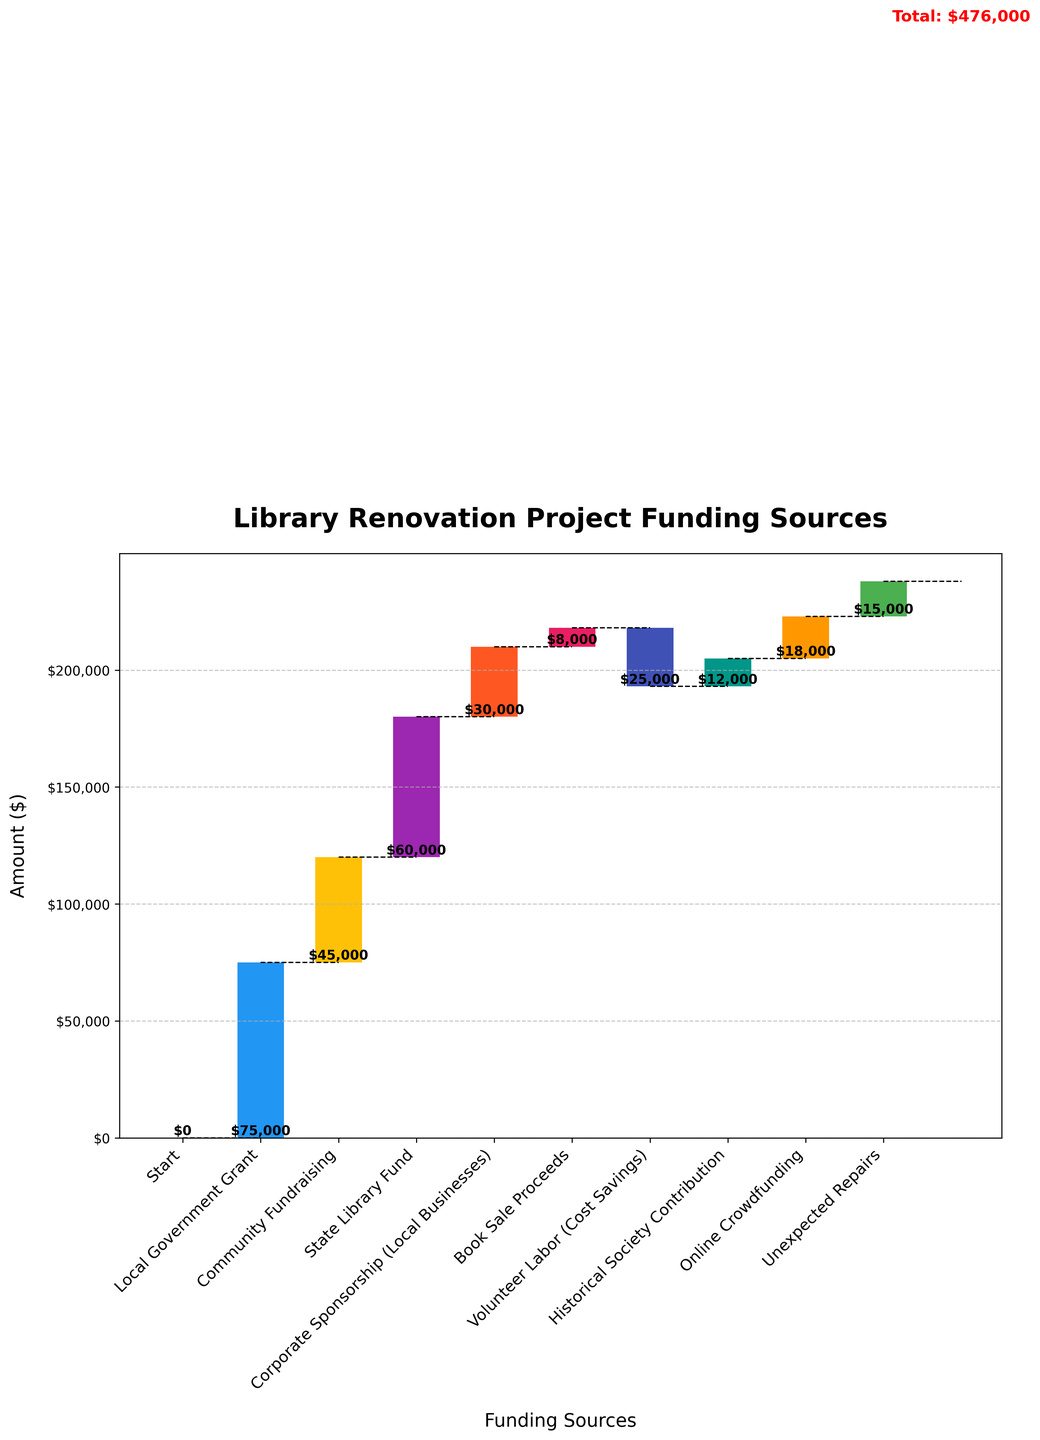What is the title of the chart? The title is displayed at the top of the chart. It is written in bold and large font.
Answer: Library Renovation Project Funding Sources What is the total amount of funding for the library renovation project? The total amount is shown as the last bar labeled "Total" in the chart, with a red value indicator.
Answer: $238,000 How much was contributed through local government grants? The contribution is shown as the first category bar after "Start".
Answer: $75,000 Which funding source contributed the least amount? To determine the least contribution, look for the smallest positive bar height in the chart.
Answer: Book Sale Proceeds ($8,000) How much cost savings was achieved through volunteer labor? The volunteer labor contribution is represented with a negative value, shown as a downward bar.
Answer: -$25,000 Which funding source contributed more, the State Library Fund or Corporate Sponsorship (Local Businesses)? Compare the heights of the bars labeled "State Library Fund" and "Corporate Sponsorship (Local Businesses)".
Answer: State Library Fund ($60,000) What was the cumulative funding after Community Fundraising? Add the value of "Local Government Grant" and "Community Fundraising" to find the cumulative amount.
Answer: $75,000 + $45,000 = $120,000 What is the net effect of Unexpected Repairs on the total funding? Unexpected Repairs is indicated with a positive value, meaning additional costs which reduce the funding, seen with an upward bar.
Answer: -$15,000 How many funding sources are there excluding the "Start" and "Total" categories? Count the bars excluding the initial "Start" and final "Total" categories.
Answer: 8 If Unexpected Repairs were not needed, what would the new total funding amount be? Remove the $15,000 of Unexpected Repairs from the total funding of $238,000.
Answer: $238,000 - $15,000 = $223,000 